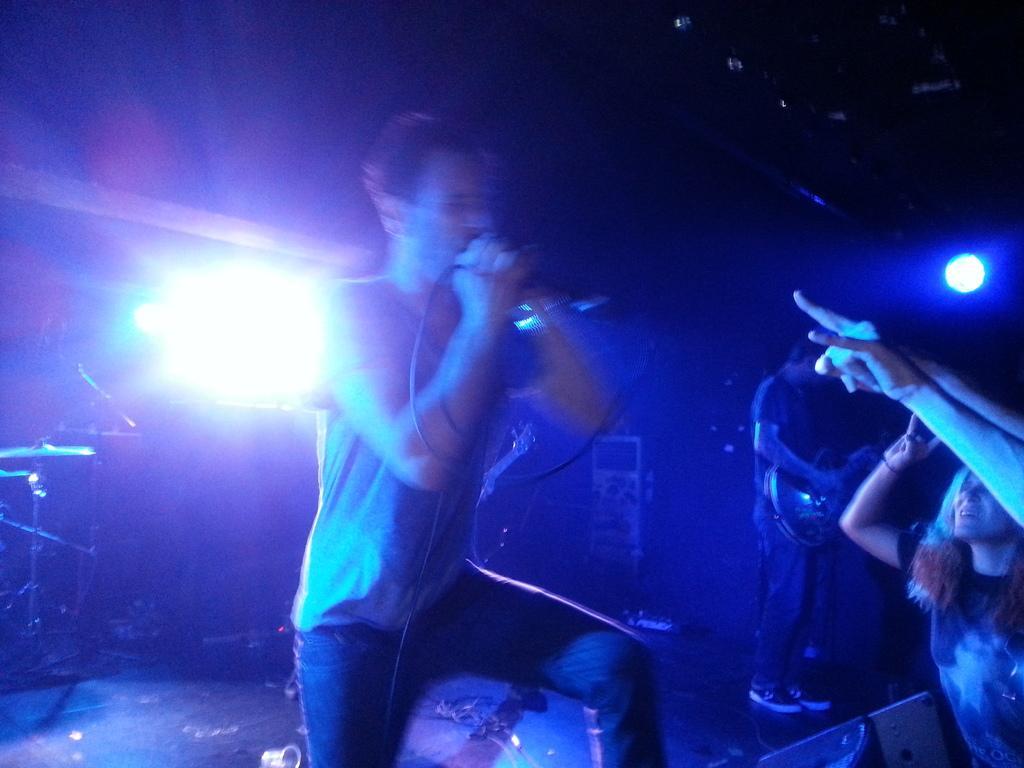How would you summarize this image in a sentence or two? There are people and this person holding guitar. Background we can see focusing lights,drum plates and it is dark. 